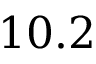<formula> <loc_0><loc_0><loc_500><loc_500>1 0 . 2</formula> 